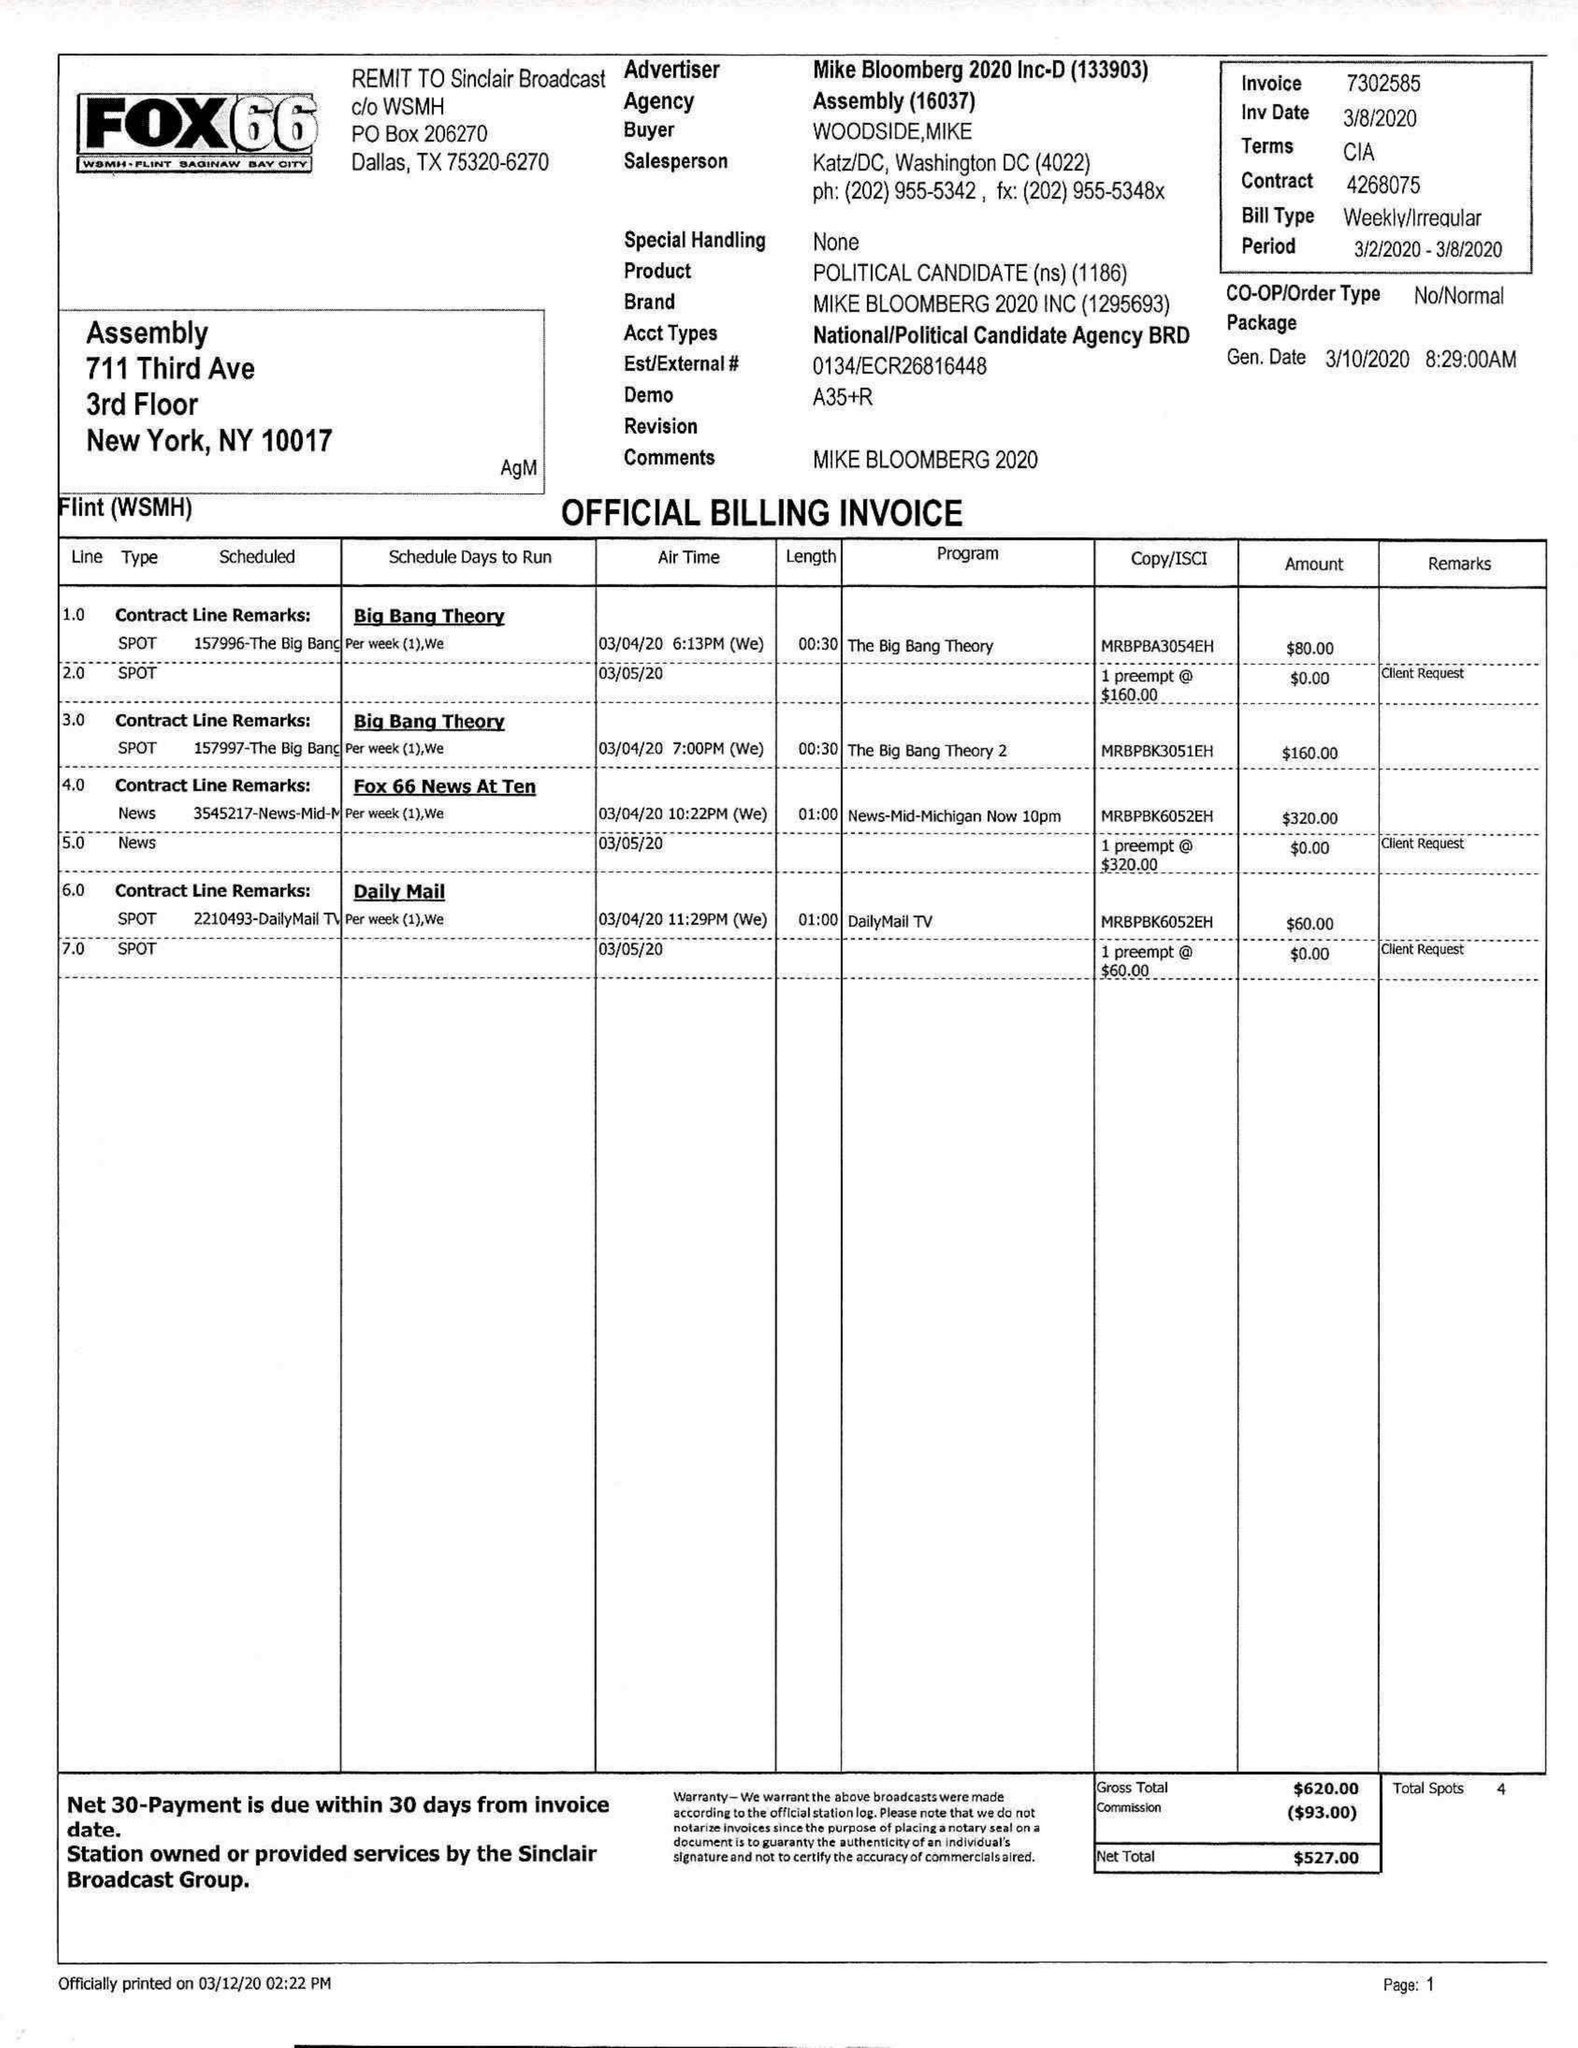What is the value for the gross_amount?
Answer the question using a single word or phrase. 620.00 